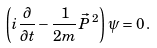<formula> <loc_0><loc_0><loc_500><loc_500>\left ( i \frac { \partial } { \partial t } - \frac { 1 } { 2 m } \vec { P } { \, } ^ { 2 } \right ) { \psi } = 0 \, .</formula> 